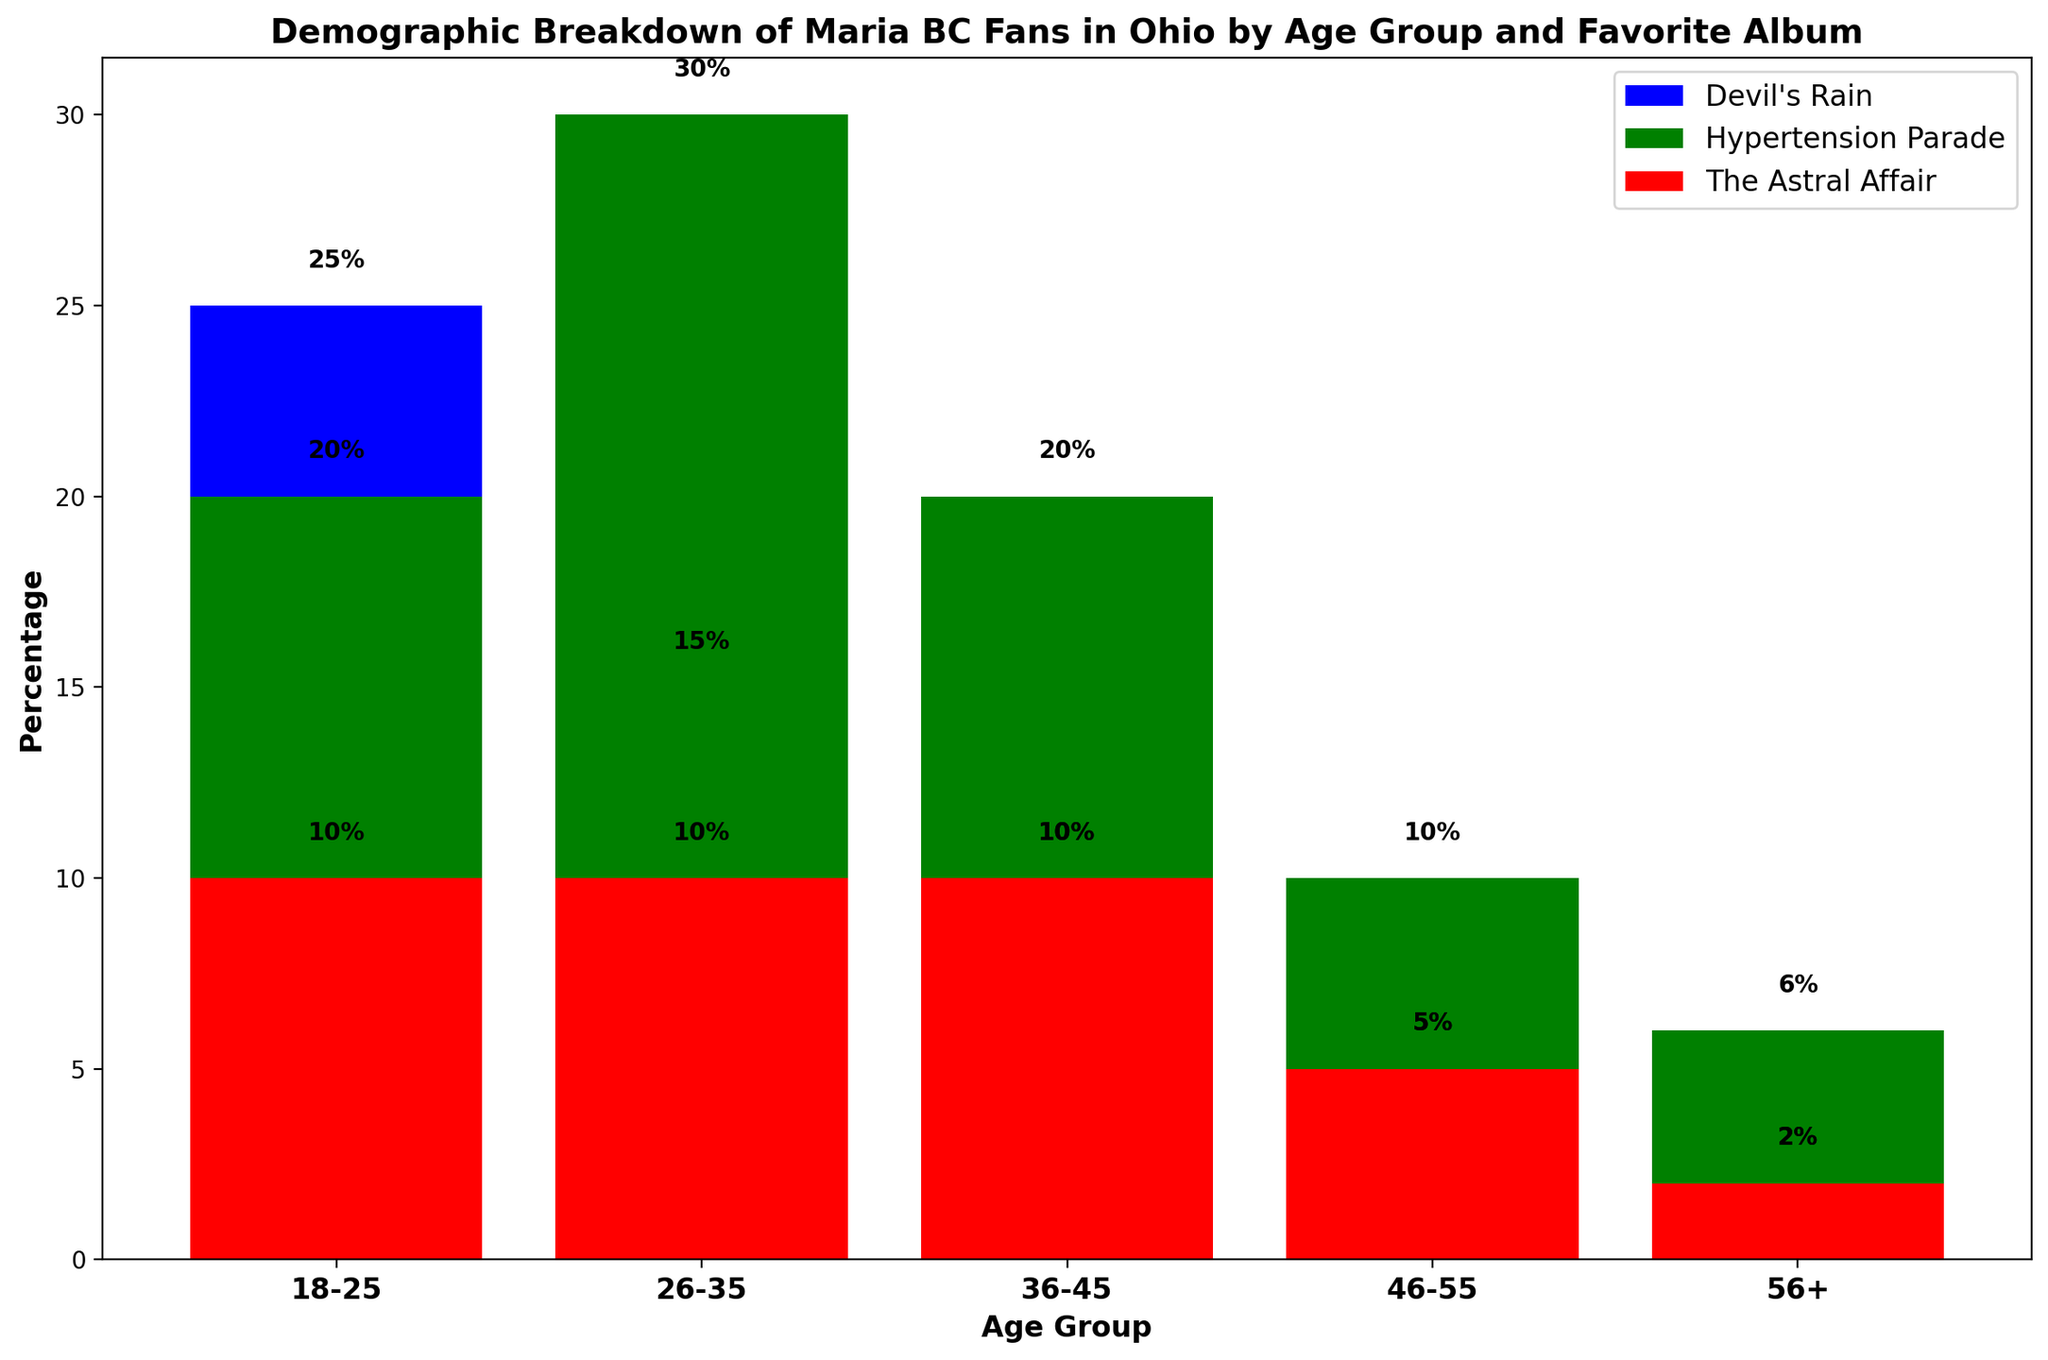Which age group has the highest percentage of fans whose favorite album is 'Hypertension Parade'? The age group 26-35 has the highest percentage at 30% for 'Hypertension Parade', as indicated by the green bars.
Answer: 26-35 Which album is the least favorite among fans aged 46-55? 'The Astral Affair' and 'Devil's Rain' are tied at 5% each, which are the lowest percentages in the 46-55 age group.
Answer: 'The Astral Affair' and 'Devil's Rain' What's the total percentage of fans aged 36-45 who favor 'Devil's Rain' and 'The Astral Affair' combined? The percentages are 10% for 'Devil's Rain' and 10% for 'The Astral Affair'. Adding these gives 10% + 10% = 20%.
Answer: 20% Compare the percentages of fans aged 56+ who prefer 'Hypertension Parade' and 'Devil's Rain'. Which is higher and by how much? For age group 56+, 'Hypertension Parade' has 6% and 'Devil's Rain' has 2%. The difference is 6% - 2% = 4%.
Answer: 'Hypertension Parade' by 4% Which age group has the smallest percentage of fans for 'The Astral Affair'? The age group of 56+ has the smallest percentage for 'The Astral Affair' at 2%, as shown by the red bar.
Answer: 56+ How much higher is the percentage of fans aged 18-25 who prefer 'Devil's Rain' compared to those aged 46-55? For the age group 18-25, the percentage is 25%. For age group 46-55, it is 5%. The difference is 25% - 5% = 20%.
Answer: 20% What's the total percentage of fans whose favorite album is 'Hypertension Parade' across all age groups? Summing the percentages: 20% (18-25) + 30% (26-35) + 20% (36-45) + 10% (46-55) + 6% (56+) = 86%.
Answer: 86% How much lower is the percentage of fans aged 56+ who prefer 'Devil's Rain' compared to those aged 26-35? For age group 56+, the percentage is 2%. For age group 26-35, it is 15%. The difference is 15% - 2% = 13%.
Answer: 13% Which album shows a decreasing trend in preference across the increasing age groups? 'Devil's Rain' shows a decreasing trend: 25% (18-25), 15% (26-35), 10% (36-45), 5% (46-55), 2% (56+).
Answer: 'Devil's Rain' What is the percentage difference between the most and least popular albums among fans aged 26-35? For age group 26-35, 'Hypertension Parade' is the most popular at 30%, and 'The Astral Affair' is the least popular at 10%. The difference is 30% - 10% = 20%.
Answer: 20% 